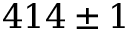<formula> <loc_0><loc_0><loc_500><loc_500>4 1 4 \pm 1</formula> 